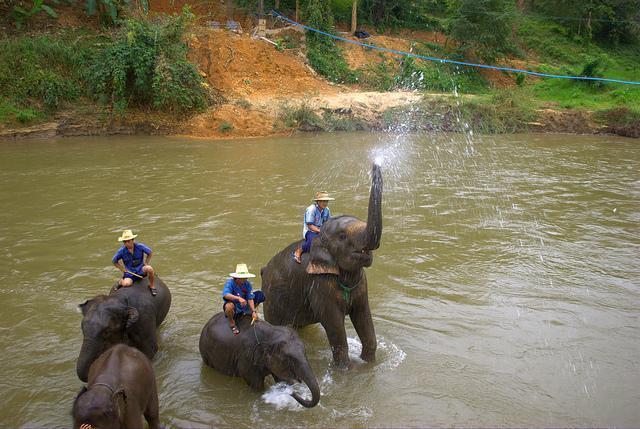How many elephants are there?
Give a very brief answer. 4. 